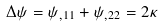<formula> <loc_0><loc_0><loc_500><loc_500>\Delta \psi = \psi _ { , 1 1 } + \psi _ { , 2 2 } = 2 \kappa</formula> 